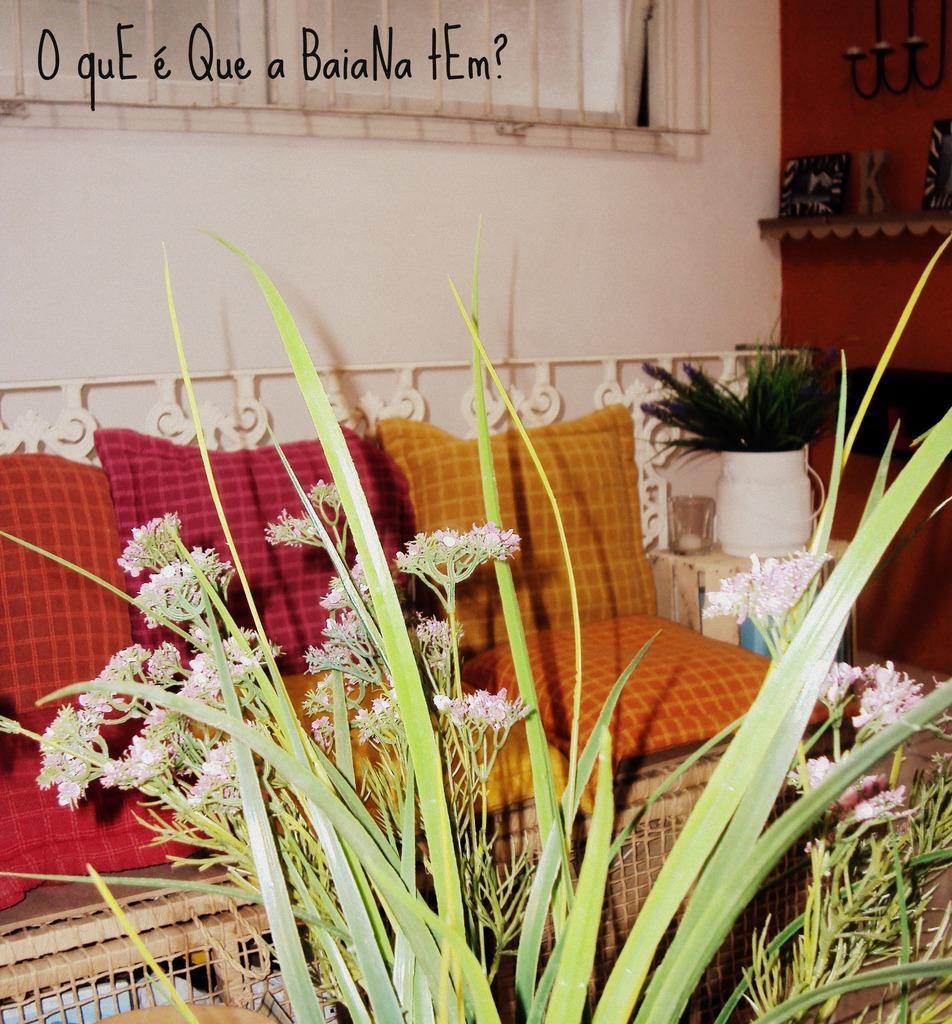Describe this image in one or two sentences. In this picture we can see flowers and flower vases, beside to the flower vase we can find a sofa and metal rods. 